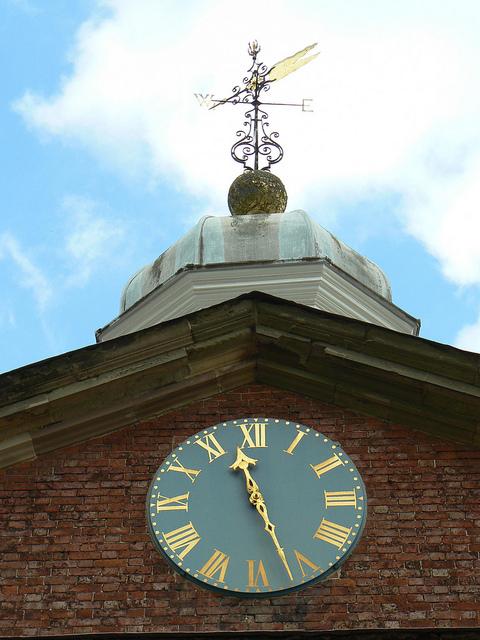What kind of numbers are on the clock?
Keep it brief. Roman numerals. Is this scene outdoors or indoors?
Write a very short answer. Outdoors. What time is displayed on the clock?
Give a very brief answer. 11:27. 